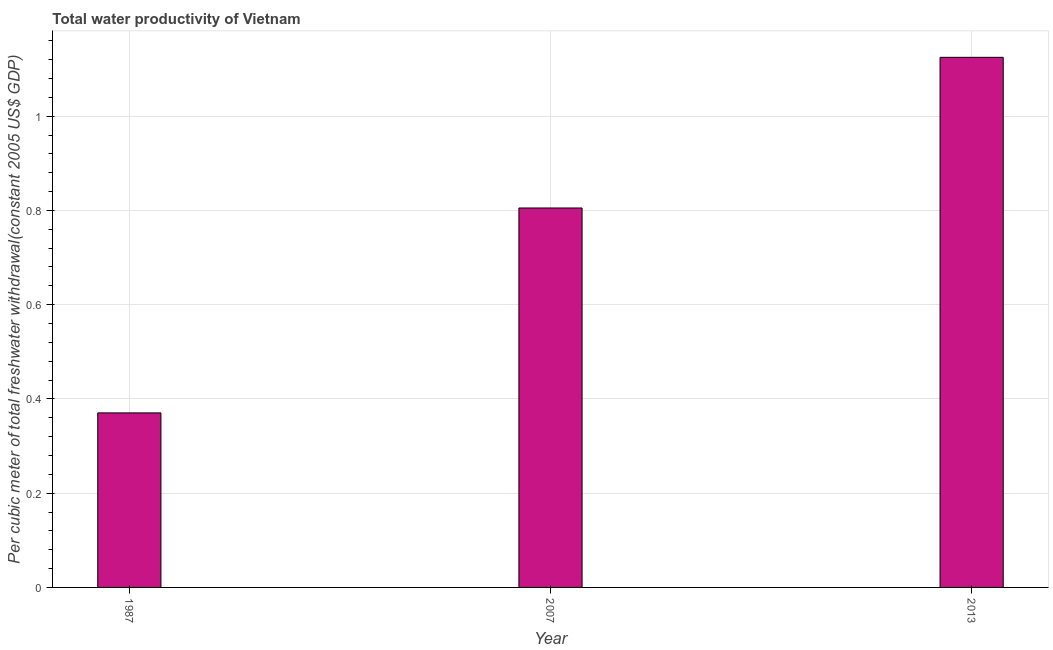Does the graph contain any zero values?
Provide a short and direct response. No. What is the title of the graph?
Provide a short and direct response. Total water productivity of Vietnam. What is the label or title of the X-axis?
Provide a succinct answer. Year. What is the label or title of the Y-axis?
Give a very brief answer. Per cubic meter of total freshwater withdrawal(constant 2005 US$ GDP). What is the total water productivity in 2013?
Provide a succinct answer. 1.12. Across all years, what is the maximum total water productivity?
Provide a succinct answer. 1.12. Across all years, what is the minimum total water productivity?
Make the answer very short. 0.37. What is the sum of the total water productivity?
Your answer should be compact. 2.3. What is the difference between the total water productivity in 2007 and 2013?
Offer a very short reply. -0.32. What is the average total water productivity per year?
Offer a terse response. 0.77. What is the median total water productivity?
Offer a terse response. 0.81. Do a majority of the years between 2007 and 2013 (inclusive) have total water productivity greater than 0.68 US$?
Your response must be concise. Yes. What is the ratio of the total water productivity in 2007 to that in 2013?
Offer a very short reply. 0.72. Is the total water productivity in 1987 less than that in 2013?
Offer a very short reply. Yes. Is the difference between the total water productivity in 2007 and 2013 greater than the difference between any two years?
Give a very brief answer. No. What is the difference between the highest and the second highest total water productivity?
Give a very brief answer. 0.32. What is the difference between the highest and the lowest total water productivity?
Make the answer very short. 0.75. Are all the bars in the graph horizontal?
Offer a very short reply. No. How many years are there in the graph?
Offer a terse response. 3. What is the difference between two consecutive major ticks on the Y-axis?
Your answer should be very brief. 0.2. Are the values on the major ticks of Y-axis written in scientific E-notation?
Keep it short and to the point. No. What is the Per cubic meter of total freshwater withdrawal(constant 2005 US$ GDP) in 1987?
Ensure brevity in your answer.  0.37. What is the Per cubic meter of total freshwater withdrawal(constant 2005 US$ GDP) in 2007?
Your answer should be compact. 0.81. What is the Per cubic meter of total freshwater withdrawal(constant 2005 US$ GDP) in 2013?
Keep it short and to the point. 1.12. What is the difference between the Per cubic meter of total freshwater withdrawal(constant 2005 US$ GDP) in 1987 and 2007?
Your answer should be compact. -0.43. What is the difference between the Per cubic meter of total freshwater withdrawal(constant 2005 US$ GDP) in 1987 and 2013?
Offer a terse response. -0.75. What is the difference between the Per cubic meter of total freshwater withdrawal(constant 2005 US$ GDP) in 2007 and 2013?
Your answer should be compact. -0.32. What is the ratio of the Per cubic meter of total freshwater withdrawal(constant 2005 US$ GDP) in 1987 to that in 2007?
Your answer should be compact. 0.46. What is the ratio of the Per cubic meter of total freshwater withdrawal(constant 2005 US$ GDP) in 1987 to that in 2013?
Offer a terse response. 0.33. What is the ratio of the Per cubic meter of total freshwater withdrawal(constant 2005 US$ GDP) in 2007 to that in 2013?
Your answer should be compact. 0.72. 